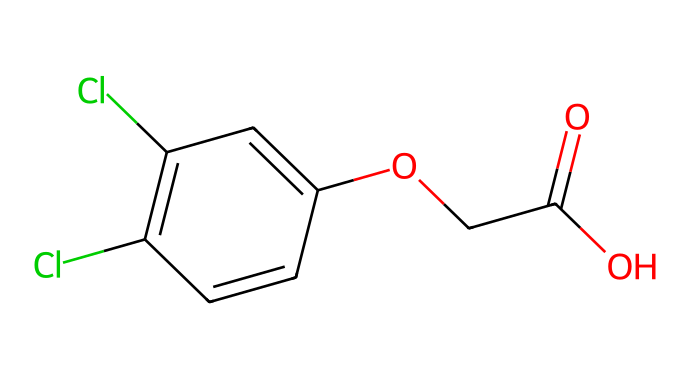What is the chemical name of this herbicide? The SMILES representation shows the structure of 2,4-Dichlorophenoxyacetic acid, as indicated by the presence of the "2,4" dichloro substituents and the "phenoxyacetic acid" part of the name.
Answer: 2,4-Dichlorophenoxyacetic acid How many chlorine atoms are present in this molecule? The SMILES notation contains two "Cl" symbols, which indicate the presence of two chlorine atoms in the structure.
Answer: 2 What functional group is present in this herbicide? The molecule features a carboxylic acid group (-COOH), as seen in the "C(=O)O" part of the SMILES, which is a defining functional group of acids.
Answer: carboxylic acid What is the total number of carbon atoms in the molecular structure? By analyzing the SMILES, we can count the number of carbon (C) symbols, which yields a total of 9 carbon atoms represented in the structure.
Answer: 9 Is this herbicide selective or non-selective for grasses? Given that 2,4-D is designed to target broadleaf weeds while being safe for grasses, it is categorized as selective.
Answer: selective What type of herbicide is 2,4-D classified as? 2,4-D is classified as a synthetic auxin, as it mimics plant hormones and affects growth processes, distinguishing it from other herbicide types.
Answer: synthetic auxin What is the role of the phenoxy group in this herbicide? The phenoxy group contributes to the herbicidal activity by altering the growth regulation in broadleaf plants, effectively incapacitating their growth.
Answer: herbicidal activity 